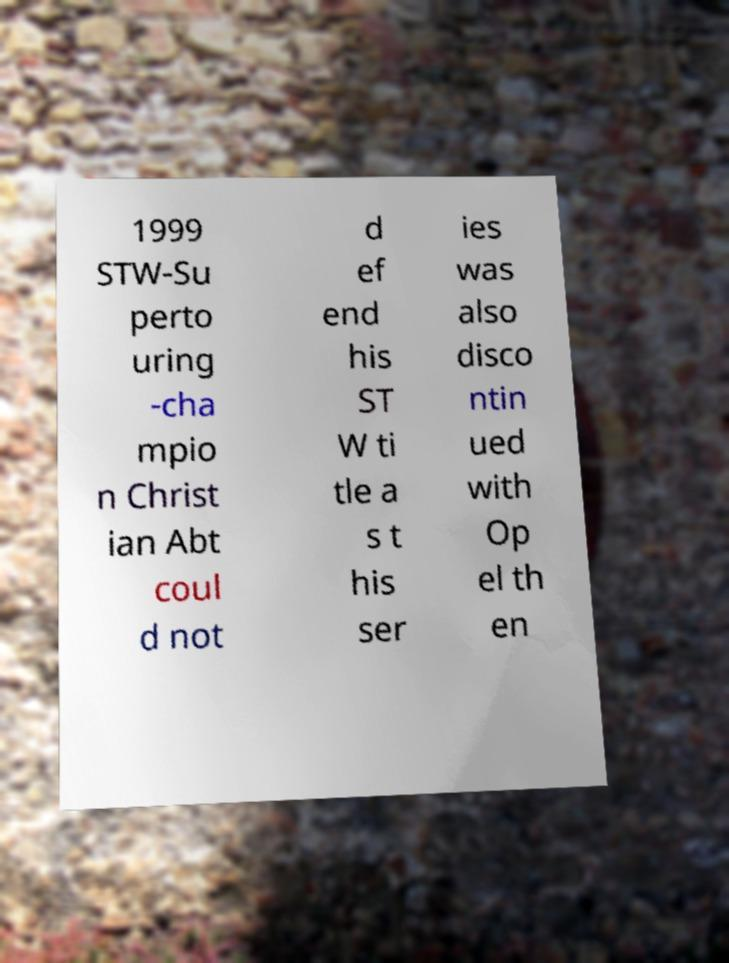Can you accurately transcribe the text from the provided image for me? 1999 STW-Su perto uring -cha mpio n Christ ian Abt coul d not d ef end his ST W ti tle a s t his ser ies was also disco ntin ued with Op el th en 